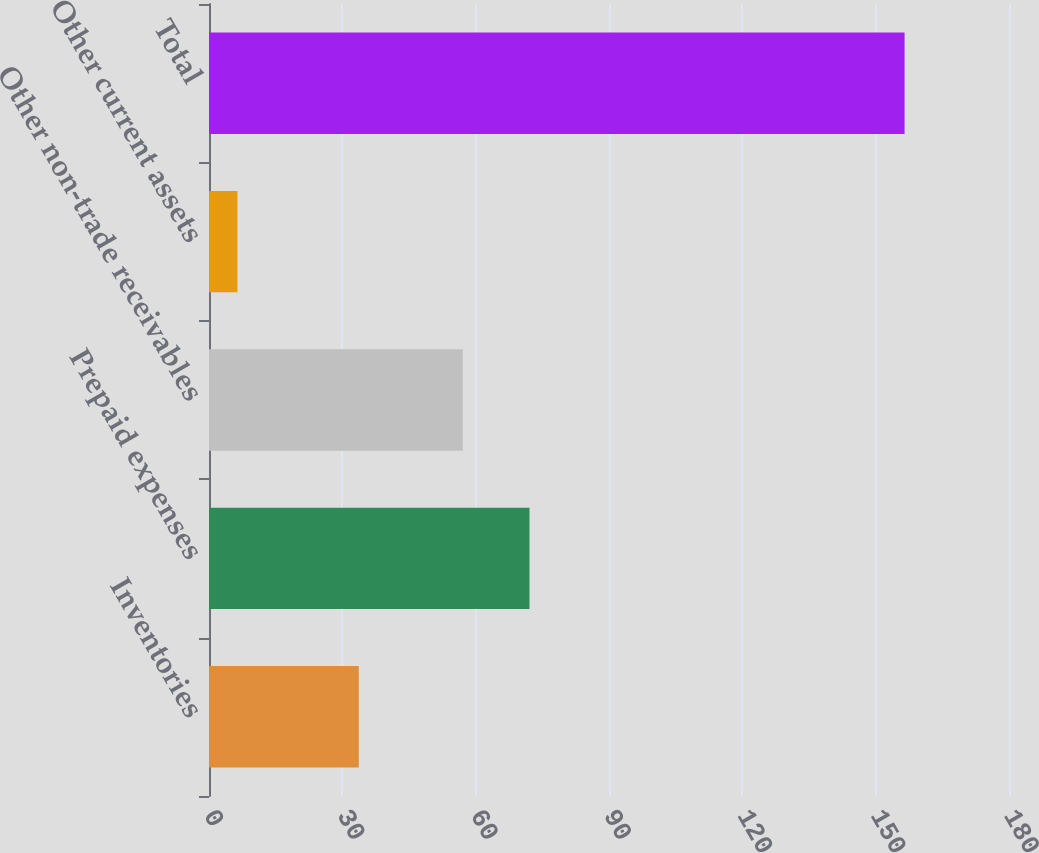Convert chart. <chart><loc_0><loc_0><loc_500><loc_500><bar_chart><fcel>Inventories<fcel>Prepaid expenses<fcel>Other non-trade receivables<fcel>Other current assets<fcel>Total<nl><fcel>33.7<fcel>72.11<fcel>57.1<fcel>6.4<fcel>156.5<nl></chart> 